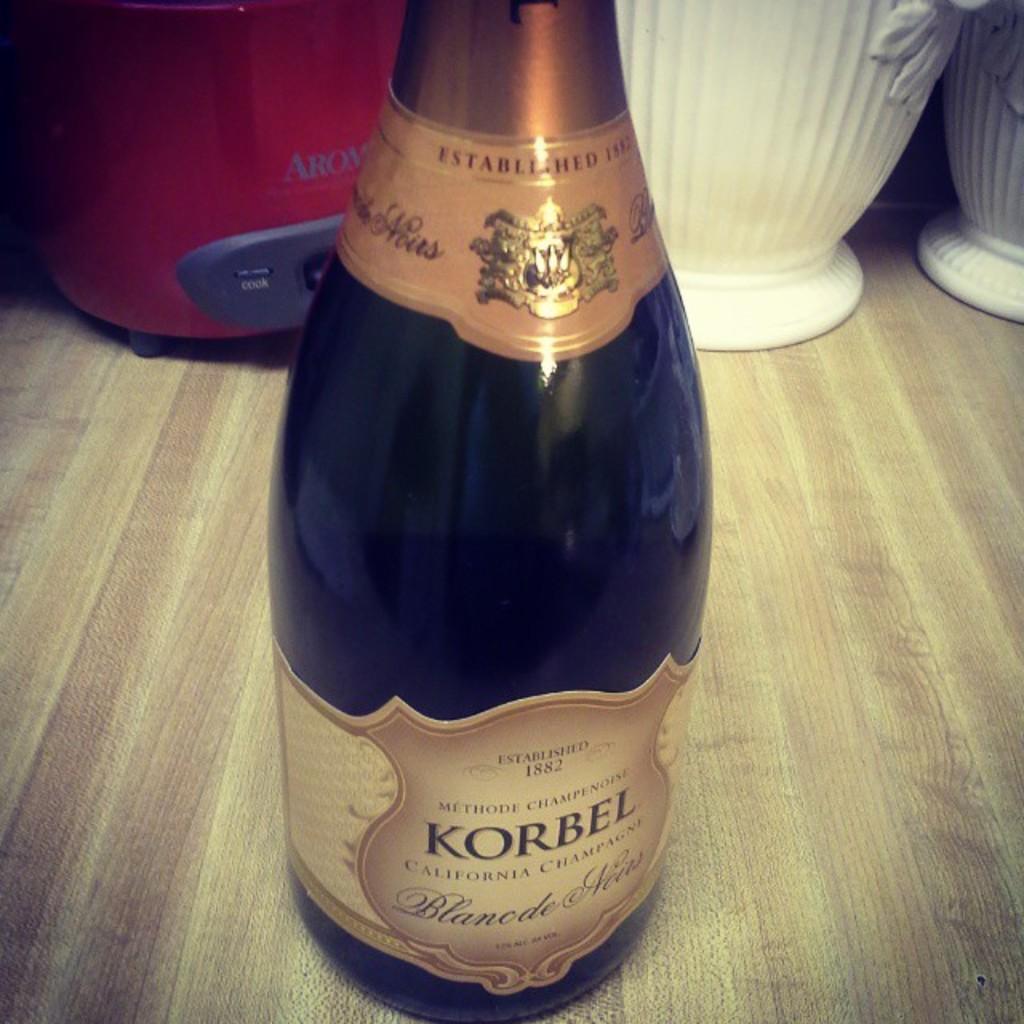What state was this champagne made in?
Provide a short and direct response. California. What is the brand of champagne?
Provide a short and direct response. Korbel. 